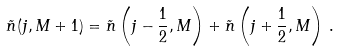Convert formula to latex. <formula><loc_0><loc_0><loc_500><loc_500>\tilde { n } ( j , M + 1 ) = \tilde { n } \left ( j - \frac { 1 } { 2 } , M \right ) + \tilde { n } \left ( j + \frac { 1 } { 2 } , M \right ) \, .</formula> 